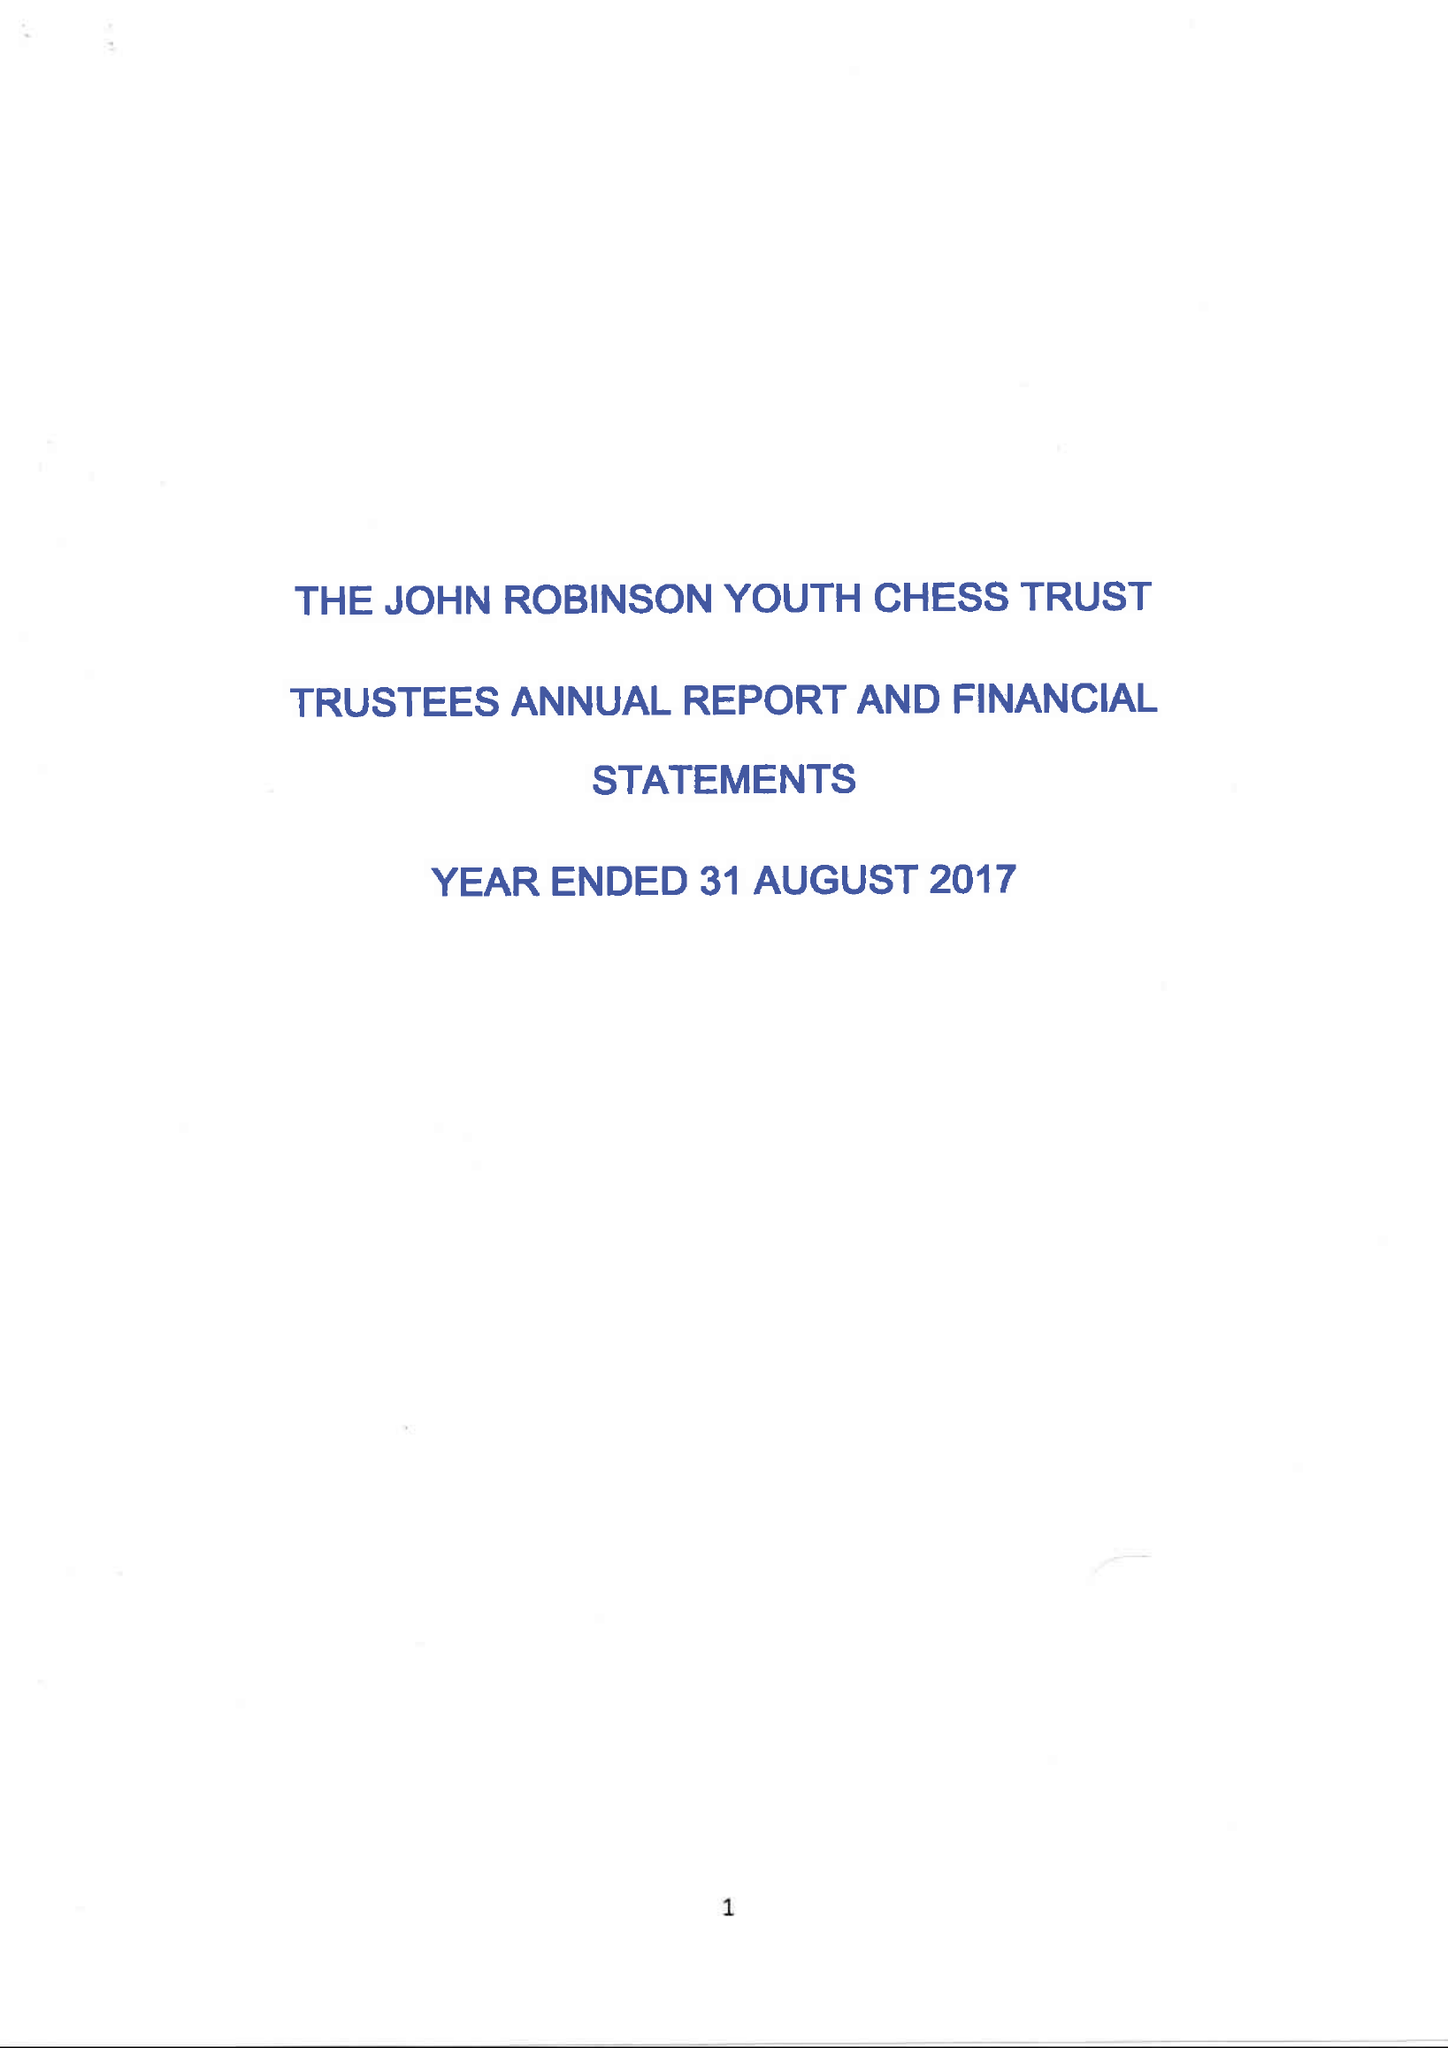What is the value for the charity_name?
Answer the question using a single word or phrase. The John Robinson Youth Chess Trust 